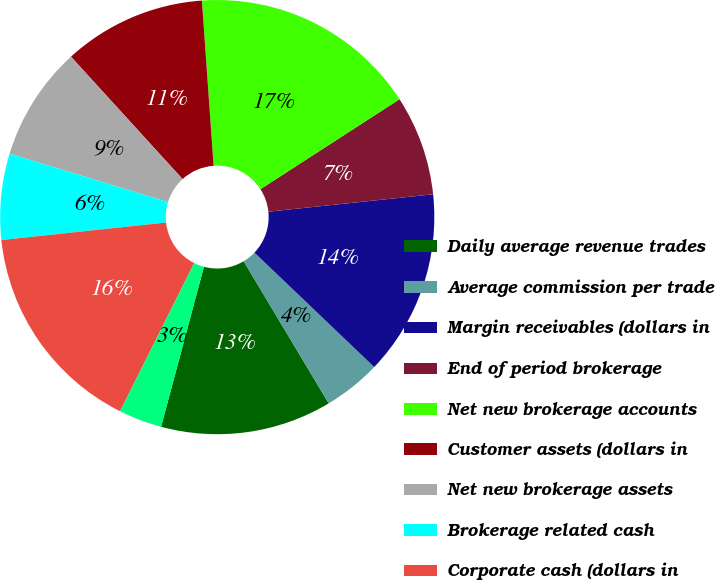Convert chart. <chart><loc_0><loc_0><loc_500><loc_500><pie_chart><fcel>Daily average revenue trades<fcel>Average commission per trade<fcel>Margin receivables (dollars in<fcel>End of period brokerage<fcel>Net new brokerage accounts<fcel>Customer assets (dollars in<fcel>Net new brokerage assets<fcel>Brokerage related cash<fcel>Corporate cash (dollars in<fcel>ETRADE Financial Tier 1<nl><fcel>12.75%<fcel>4.28%<fcel>13.81%<fcel>7.46%<fcel>16.99%<fcel>10.64%<fcel>8.52%<fcel>6.4%<fcel>15.93%<fcel>3.22%<nl></chart> 